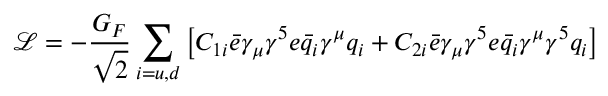Convert formula to latex. <formula><loc_0><loc_0><loc_500><loc_500>\mathcal { L } = - \frac { G _ { F } } { \sqrt { 2 } } \sum _ { i = u , d } \left [ C _ { 1 i } \bar { e } \gamma _ { \mu } \gamma ^ { 5 } e \bar { q } _ { i } \gamma ^ { \mu } q _ { i } + C _ { 2 i } \bar { e } \gamma _ { \mu } \gamma ^ { 5 } e \bar { q } _ { i } \gamma ^ { \mu } \gamma ^ { 5 } q _ { i } \right ]</formula> 